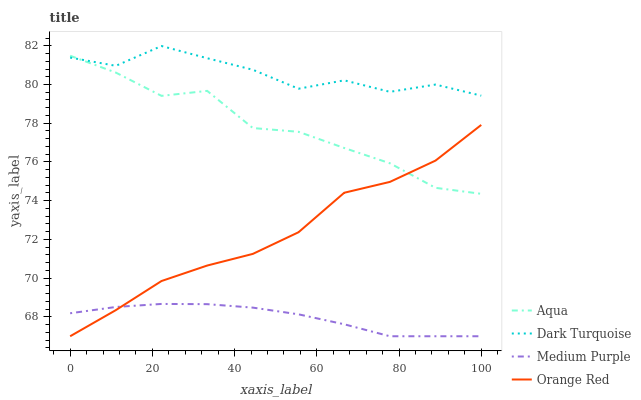Does Aqua have the minimum area under the curve?
Answer yes or no. No. Does Aqua have the maximum area under the curve?
Answer yes or no. No. Is Aqua the smoothest?
Answer yes or no. No. Is Aqua the roughest?
Answer yes or no. No. Does Aqua have the lowest value?
Answer yes or no. No. Does Aqua have the highest value?
Answer yes or no. No. Is Medium Purple less than Aqua?
Answer yes or no. Yes. Is Dark Turquoise greater than Orange Red?
Answer yes or no. Yes. Does Medium Purple intersect Aqua?
Answer yes or no. No. 